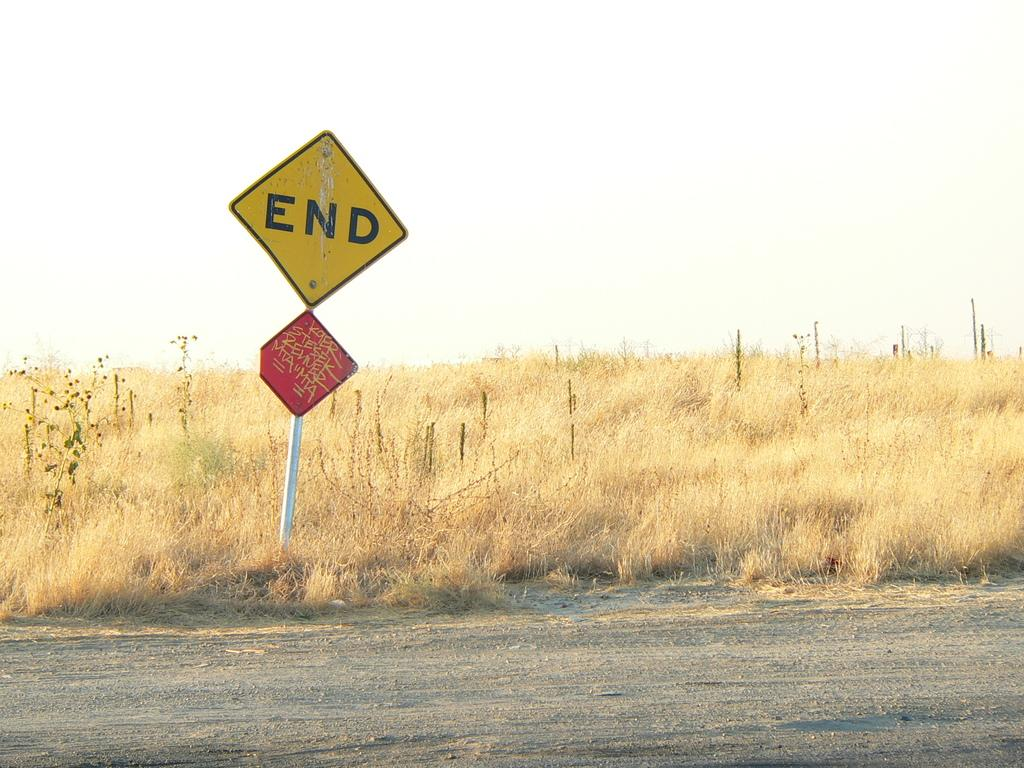What is the main object in the image? There is a sign board in the image. What type of surface is visible beneath the sign board? There is grass in the image. What can be seen in the background of the image? The sky is visible in the background of the image. How many pigs are visible in the image? There are no pigs present in the image. What type of iron object can be seen in the image? There is no iron object present in the image. 